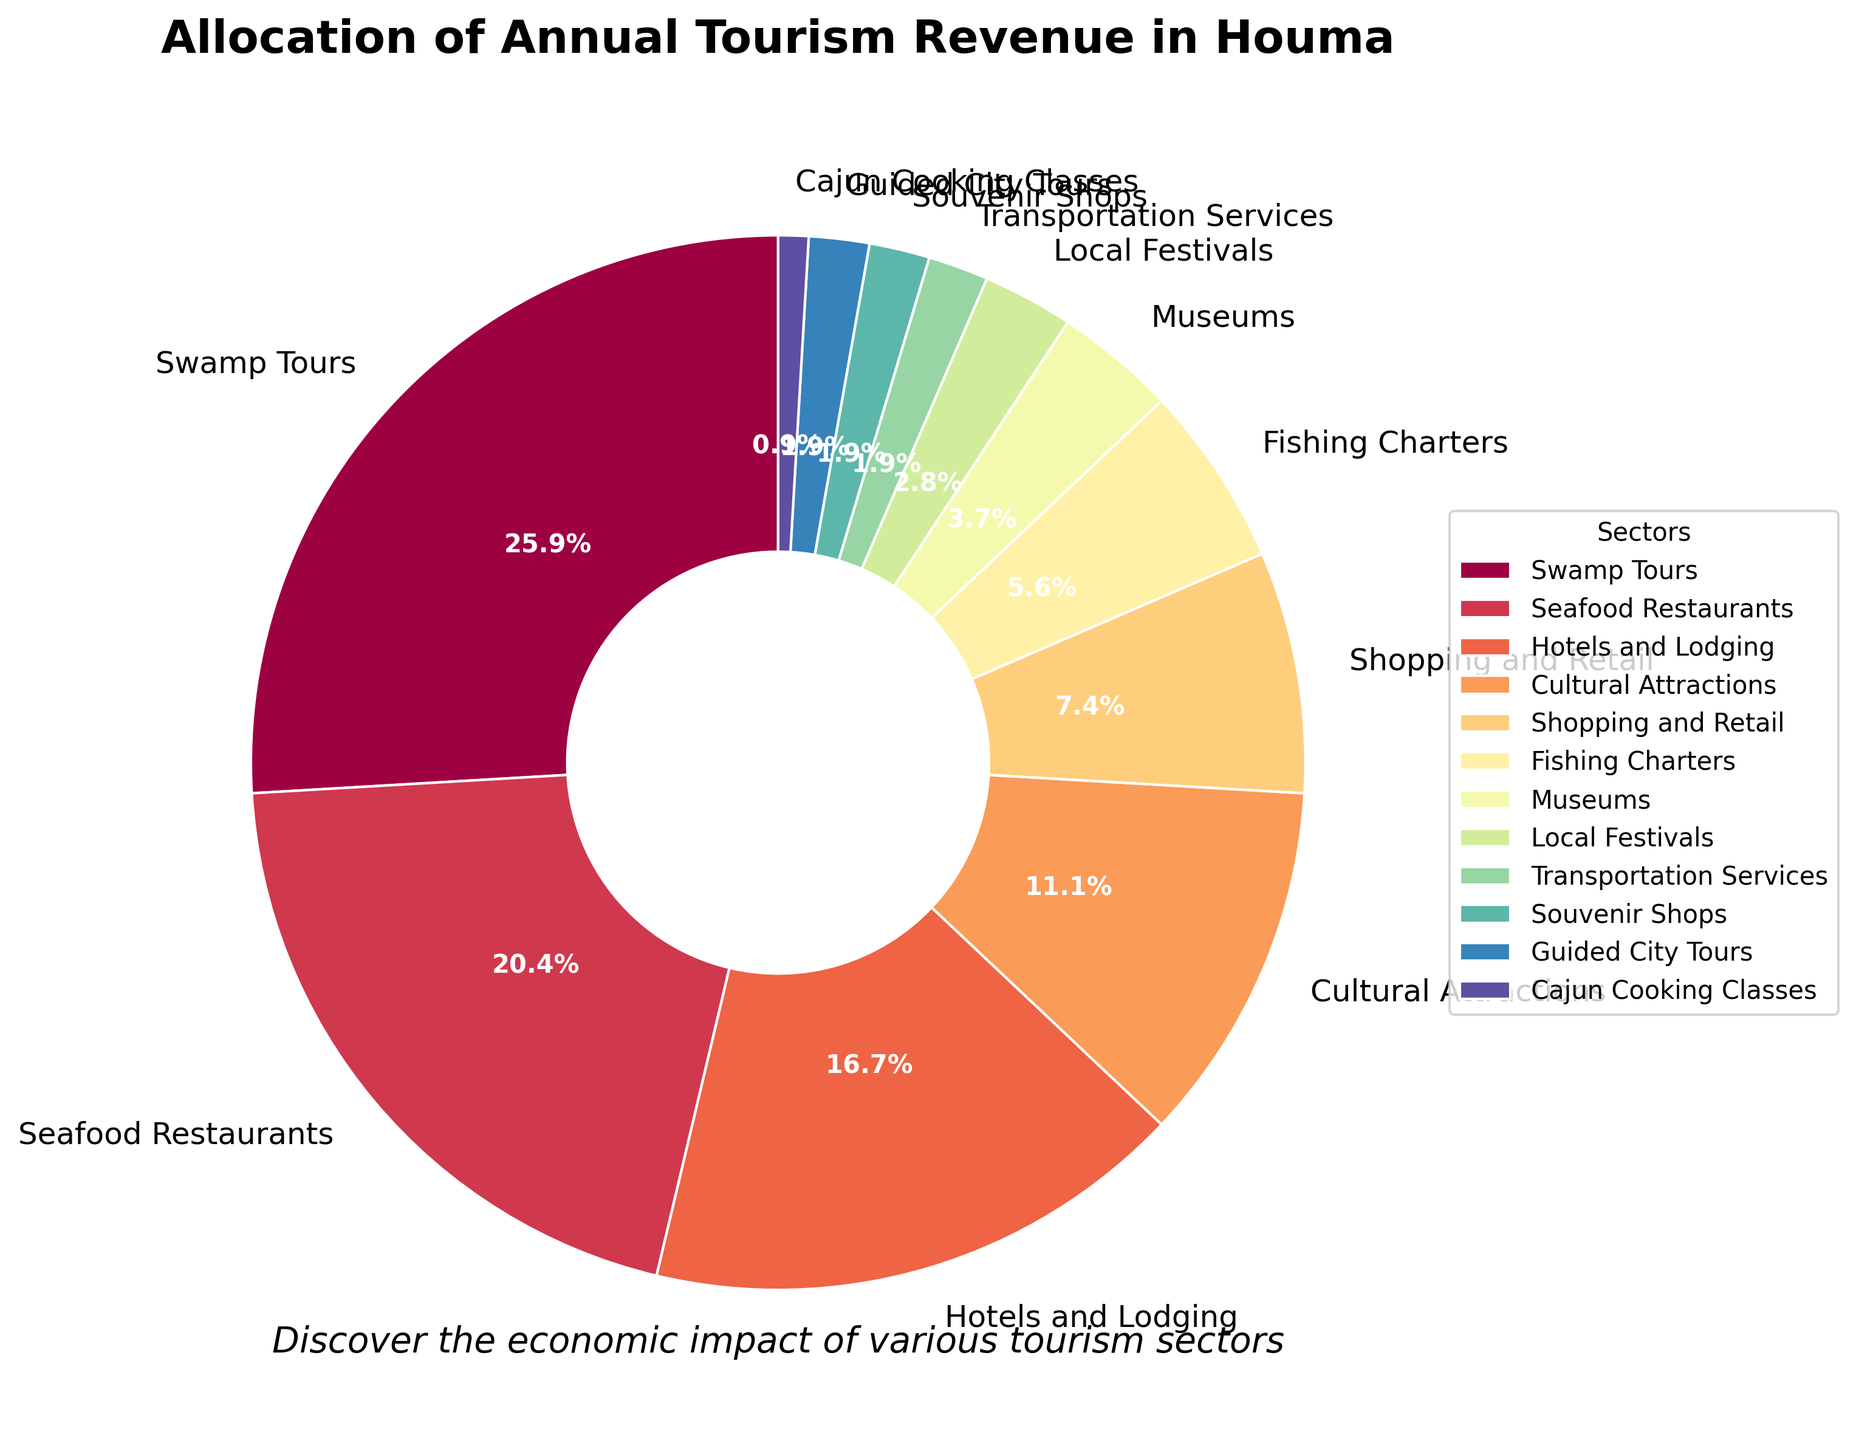Which sector gets the highest percentage of tourism revenue in Houma? The sector with the largest portion of the pie chart represents the highest percentage of tourism revenue. This is indicated by the largest section of the pie chart.
Answer: Swamp Tours Which two sectors together make up half of the tourism revenue allocation? Adding up the percentages from the pie chart, Swamp Tours (28%) and Seafood Restaurants (22%) together make up 50% of the total revenue.
Answer: Swamp Tours and Seafood Restaurants What percentage of revenue is allocated to Cultural Attractions and Museums combined? By adding the percentage of Cultural Attractions (12%) and Museums (4%), we get the combined total. 12% + 4% = 16%
Answer: 16% Is the percentage of revenue from Hotels and Lodging higher than that from Shopping and Retail? Comparing the two wedges, Hotels and Lodging has 18% while Shopping and Retail has 8%. Thus, Hotels and Lodging is higher.
Answer: Yes What is the revenue percentage difference between Fishing Charters and Local Festivals? Subtract the percentage for Local Festivals (3%) from Fishing Charters (6%) to get the difference: 6% - 3% = 3%
Answer: 3% What percentage of revenue do all sectors receiving less than 5% each contribute in total? Summing up the percentages for Museums (4%), Local Festivals (3%), Transportation Services (2%), Souvenir Shops (2%), Guided City Tours (2%), and Cajun Cooking Classes (1%): 4% + 3% + 2% + 2% + 2% + 1% = 14%
Answer: 14% How much larger is the revenue percentage for Swamp Tours compared to Hotels and Lodging? Subtracting Hotels and Lodging (18%) from Swamp Tours (28%): 28% - 18% = 10%
Answer: 10% What are the colors used to represent Seafood Restaurants and Swamp Tours respectively? The colors for each sector can be identified visually on the chart. The wedges for these sectors are distinct in color. Seafood Restaurants are typically represented in one color, and Swamp Tours in another that is visually distinguishable.
Answer: (Based on the created color palette in the code, answers might vary but let's assume) Purple for Seafood Restaurants, and Yellow for Swamp Tours 